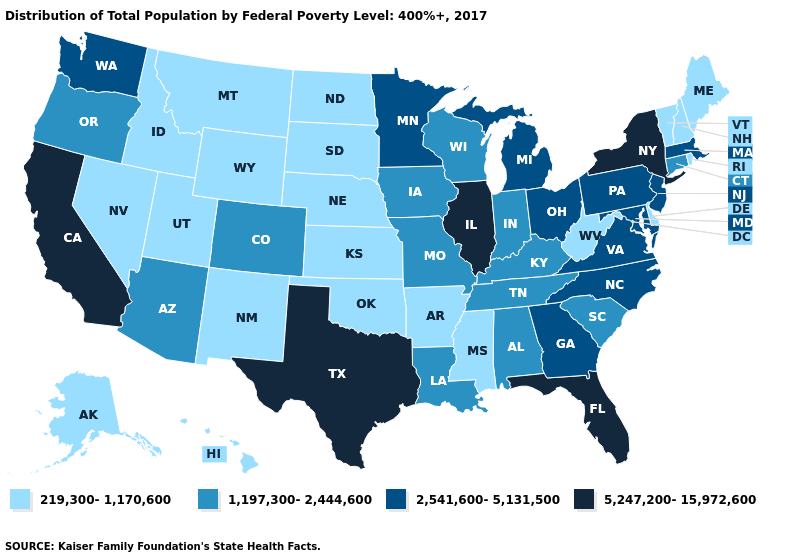What is the highest value in the Northeast ?
Short answer required. 5,247,200-15,972,600. Does the map have missing data?
Answer briefly. No. What is the highest value in states that border Massachusetts?
Answer briefly. 5,247,200-15,972,600. How many symbols are there in the legend?
Be succinct. 4. Name the states that have a value in the range 1,197,300-2,444,600?
Quick response, please. Alabama, Arizona, Colorado, Connecticut, Indiana, Iowa, Kentucky, Louisiana, Missouri, Oregon, South Carolina, Tennessee, Wisconsin. Name the states that have a value in the range 2,541,600-5,131,500?
Be succinct. Georgia, Maryland, Massachusetts, Michigan, Minnesota, New Jersey, North Carolina, Ohio, Pennsylvania, Virginia, Washington. Is the legend a continuous bar?
Answer briefly. No. How many symbols are there in the legend?
Write a very short answer. 4. What is the value of Colorado?
Quick response, please. 1,197,300-2,444,600. Name the states that have a value in the range 1,197,300-2,444,600?
Write a very short answer. Alabama, Arizona, Colorado, Connecticut, Indiana, Iowa, Kentucky, Louisiana, Missouri, Oregon, South Carolina, Tennessee, Wisconsin. Among the states that border Oregon , which have the lowest value?
Keep it brief. Idaho, Nevada. Among the states that border New Jersey , which have the lowest value?
Quick response, please. Delaware. What is the highest value in the USA?
Give a very brief answer. 5,247,200-15,972,600. 